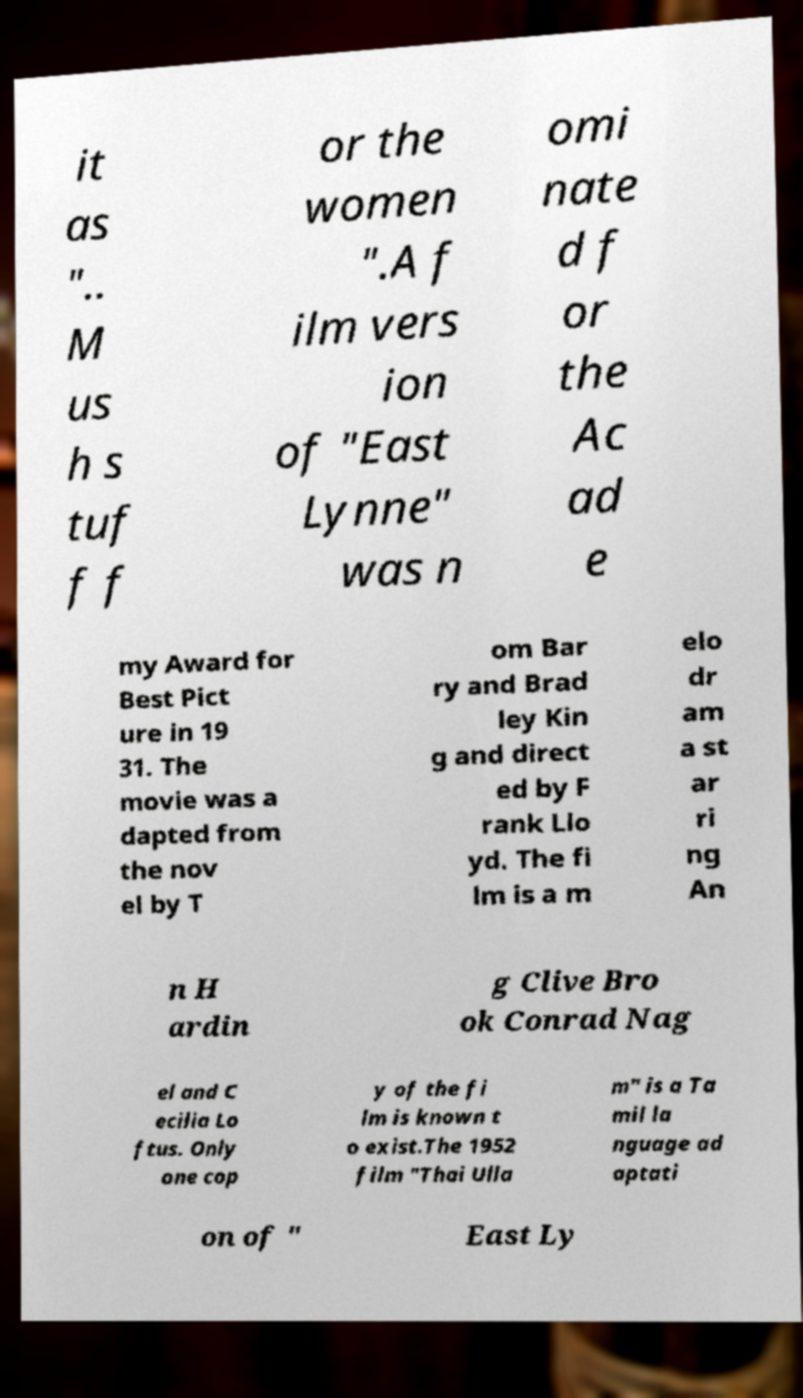Could you assist in decoding the text presented in this image and type it out clearly? it as ".. M us h s tuf f f or the women ".A f ilm vers ion of "East Lynne" was n omi nate d f or the Ac ad e my Award for Best Pict ure in 19 31. The movie was a dapted from the nov el by T om Bar ry and Brad ley Kin g and direct ed by F rank Llo yd. The fi lm is a m elo dr am a st ar ri ng An n H ardin g Clive Bro ok Conrad Nag el and C ecilia Lo ftus. Only one cop y of the fi lm is known t o exist.The 1952 film "Thai Ulla m" is a Ta mil la nguage ad aptati on of " East Ly 